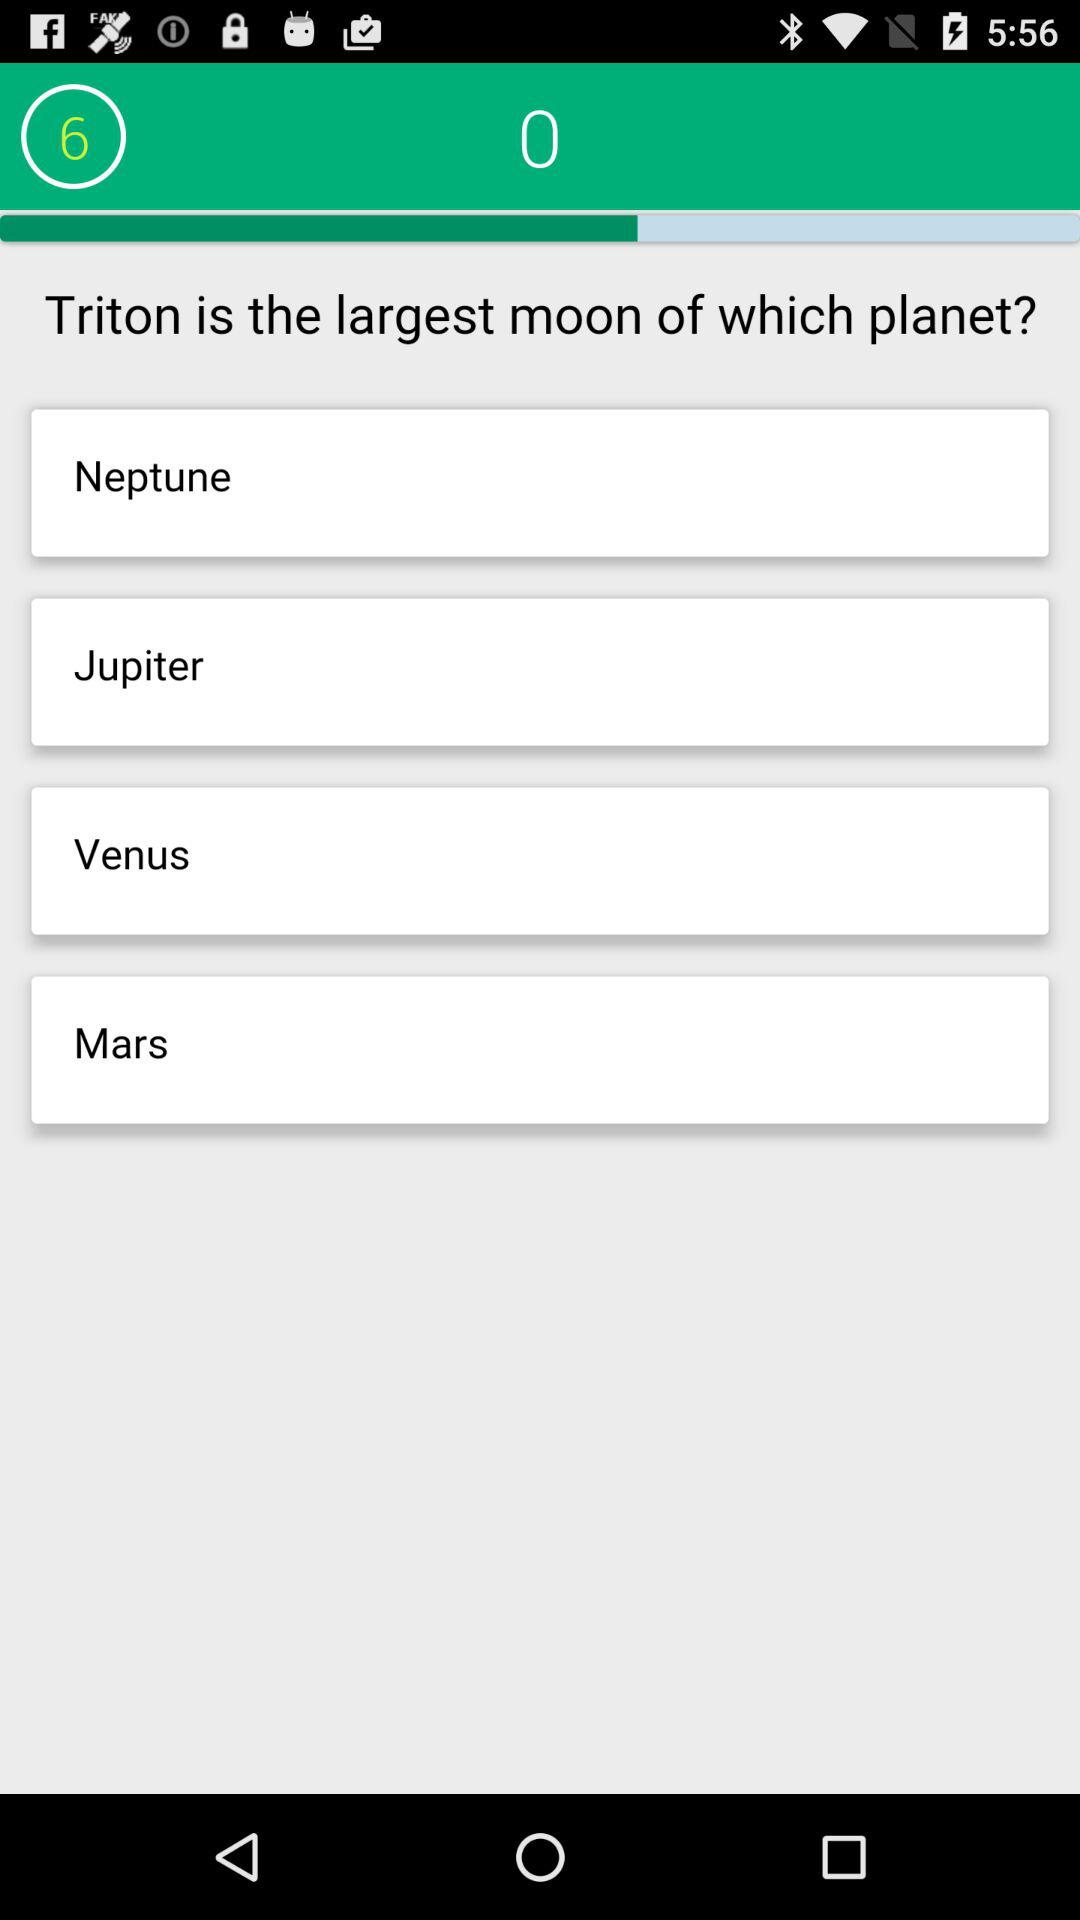What question am I on? You are on question 6. 